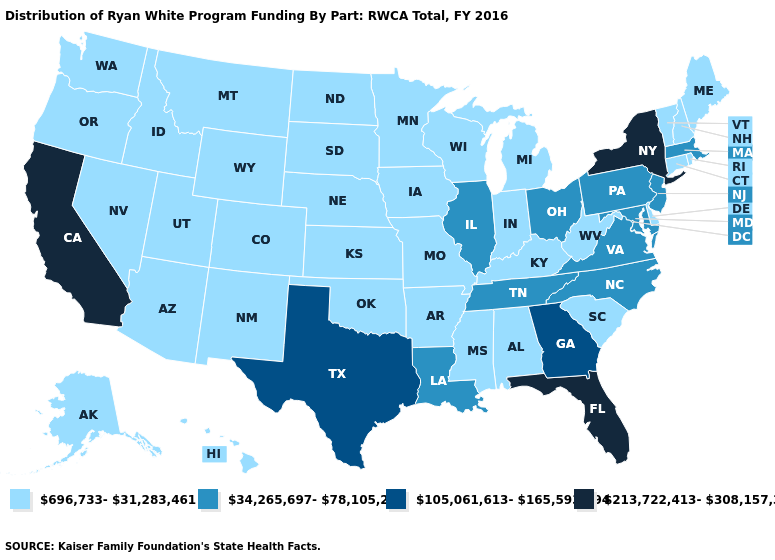Name the states that have a value in the range 696,733-31,283,461?
Concise answer only. Alabama, Alaska, Arizona, Arkansas, Colorado, Connecticut, Delaware, Hawaii, Idaho, Indiana, Iowa, Kansas, Kentucky, Maine, Michigan, Minnesota, Mississippi, Missouri, Montana, Nebraska, Nevada, New Hampshire, New Mexico, North Dakota, Oklahoma, Oregon, Rhode Island, South Carolina, South Dakota, Utah, Vermont, Washington, West Virginia, Wisconsin, Wyoming. Among the states that border New York , does Pennsylvania have the highest value?
Give a very brief answer. Yes. Which states have the lowest value in the West?
Keep it brief. Alaska, Arizona, Colorado, Hawaii, Idaho, Montana, Nevada, New Mexico, Oregon, Utah, Washington, Wyoming. What is the highest value in the Northeast ?
Short answer required. 213,722,413-308,157,325. Among the states that border Virginia , does Tennessee have the highest value?
Concise answer only. Yes. Among the states that border Oregon , does California have the highest value?
Concise answer only. Yes. What is the highest value in states that border New Jersey?
Be succinct. 213,722,413-308,157,325. Does Georgia have the lowest value in the USA?
Answer briefly. No. Name the states that have a value in the range 105,061,613-165,593,294?
Keep it brief. Georgia, Texas. Which states have the lowest value in the South?
Give a very brief answer. Alabama, Arkansas, Delaware, Kentucky, Mississippi, Oklahoma, South Carolina, West Virginia. Which states have the lowest value in the USA?
Give a very brief answer. Alabama, Alaska, Arizona, Arkansas, Colorado, Connecticut, Delaware, Hawaii, Idaho, Indiana, Iowa, Kansas, Kentucky, Maine, Michigan, Minnesota, Mississippi, Missouri, Montana, Nebraska, Nevada, New Hampshire, New Mexico, North Dakota, Oklahoma, Oregon, Rhode Island, South Carolina, South Dakota, Utah, Vermont, Washington, West Virginia, Wisconsin, Wyoming. What is the highest value in the USA?
Answer briefly. 213,722,413-308,157,325. Name the states that have a value in the range 213,722,413-308,157,325?
Be succinct. California, Florida, New York. What is the value of Florida?
Short answer required. 213,722,413-308,157,325. 